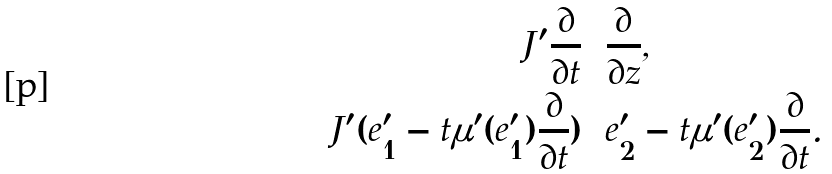Convert formula to latex. <formula><loc_0><loc_0><loc_500><loc_500>J ^ { \prime } \frac { \partial } { \partial t } & = \frac { \partial } { \partial z } , \\ J ^ { \prime } ( e _ { 1 } ^ { \prime } - t \mu ^ { \prime } ( e _ { 1 } ^ { \prime } ) \frac { \partial } { \partial t } ) & = e _ { 2 } ^ { \prime } - t \mu ^ { \prime } ( e _ { 2 } ^ { \prime } ) \frac { \partial } { \partial t } .</formula> 